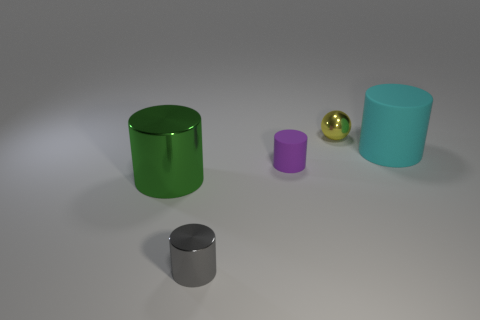Subtract all blue cylinders. Subtract all cyan blocks. How many cylinders are left? 4 Add 5 green cylinders. How many objects exist? 10 Subtract all cylinders. How many objects are left? 1 Subtract 1 green cylinders. How many objects are left? 4 Subtract all gray metallic cylinders. Subtract all small yellow balls. How many objects are left? 3 Add 4 metal things. How many metal things are left? 7 Add 2 tiny blue rubber blocks. How many tiny blue rubber blocks exist? 2 